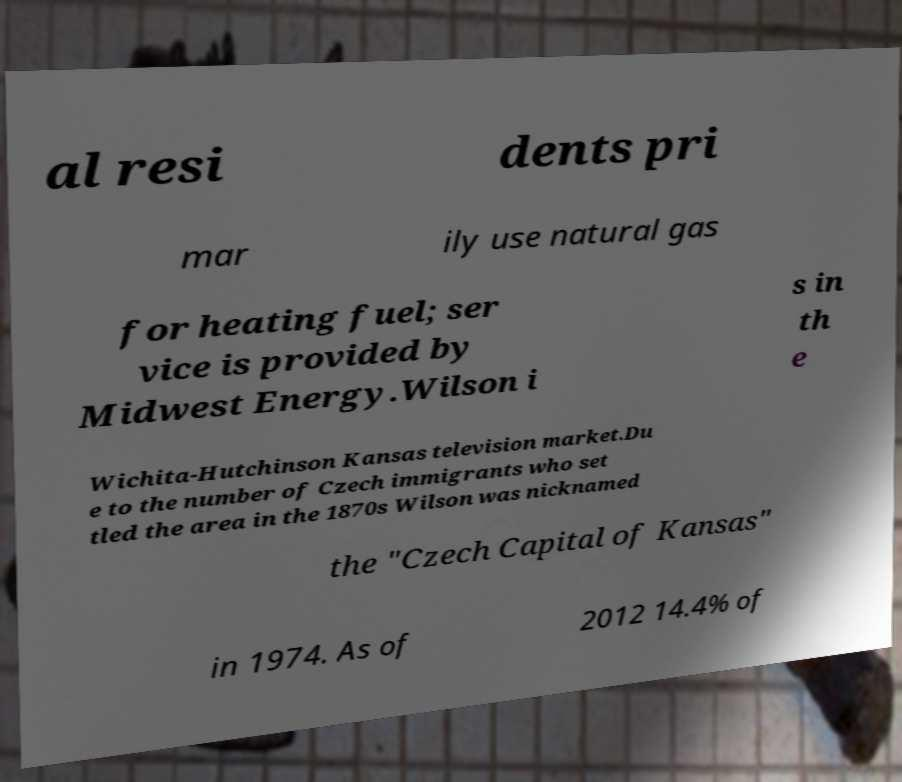Please identify and transcribe the text found in this image. al resi dents pri mar ily use natural gas for heating fuel; ser vice is provided by Midwest Energy.Wilson i s in th e Wichita-Hutchinson Kansas television market.Du e to the number of Czech immigrants who set tled the area in the 1870s Wilson was nicknamed the "Czech Capital of Kansas" in 1974. As of 2012 14.4% of 